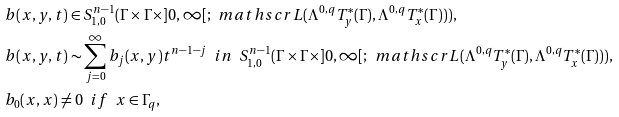<formula> <loc_0><loc_0><loc_500><loc_500>& b ( x , y , t ) \in S ^ { n - 1 } _ { 1 , 0 } ( \Gamma \times \Gamma \times ] 0 , \infty [ ; \, \ m a t h s c r L ( \Lambda ^ { 0 , q } T ^ { * } _ { y } ( \Gamma ) , \Lambda ^ { 0 , q } T ^ { * } _ { x } ( \Gamma ) ) ) , \\ & b ( x , y , t ) \sim \sum ^ { \infty } _ { j = 0 } b _ { j } ( x , y ) t ^ { n - 1 - j } \ \ i n \ \ S ^ { n - 1 } _ { 1 , 0 } ( \Gamma \times \Gamma \times ] 0 , \infty [ ; \, \ m a t h s c r L ( \Lambda ^ { 0 , q } T ^ { * } _ { y } ( \Gamma ) , \Lambda ^ { 0 , q } T ^ { * } _ { x } ( \Gamma ) ) ) , \\ & b _ { 0 } ( x , x ) \neq 0 \ \ i f \ \ x \in \Gamma _ { q } ,</formula> 